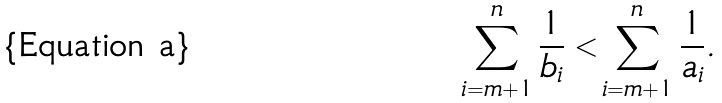<formula> <loc_0><loc_0><loc_500><loc_500>\sum _ { i = m + 1 } ^ { n } \frac { 1 } { b _ { i } } < \sum _ { i = m + 1 } ^ { n } \frac { 1 } { a _ { i } } .</formula> 